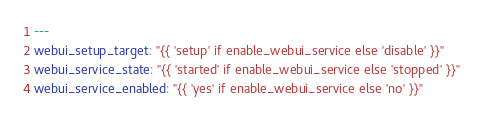<code> <loc_0><loc_0><loc_500><loc_500><_YAML_>---
webui_setup_target: "{{ 'setup' if enable_webui_service else 'disable' }}"
webui_service_state: "{{ 'started' if enable_webui_service else 'stopped' }}"
webui_service_enabled: "{{ 'yes' if enable_webui_service else 'no' }}"
</code> 